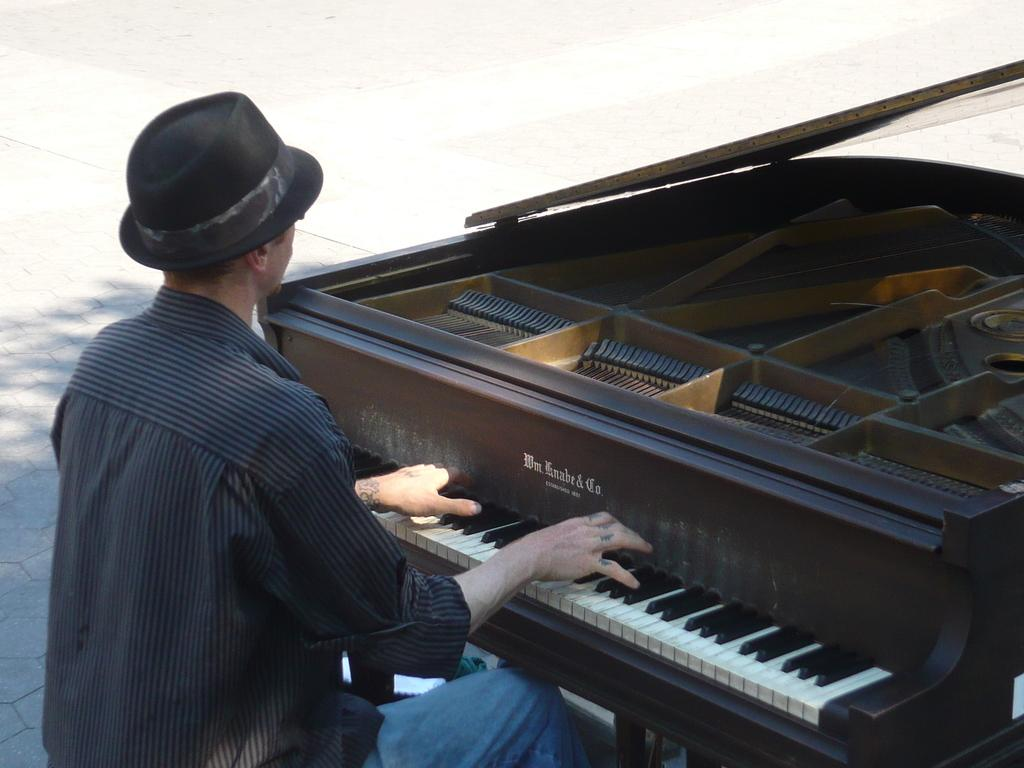What is the person in the image doing? The person is playing a piano. Can you describe the person's clothing in the image? The person is wearing a cap. What else can be seen in the image besides the person and the piano? There is a road visible in the image. What type of coat is the person wearing in the image? The person is not wearing a coat in the image; they are wearing a cap. Can you describe the bushes on the side of the road in the image? There are no bushes visible in the image; only a road and a person playing the piano are present. 